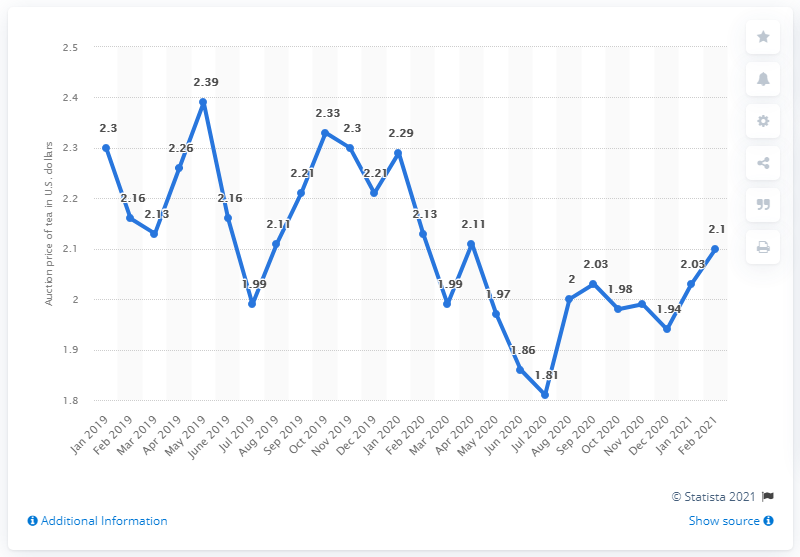Outline some significant characteristics in this image. In May 2019, the average price of tea was 2.39 U.S. dollars. 